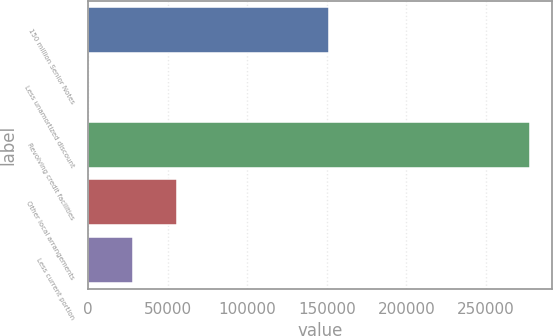<chart> <loc_0><loc_0><loc_500><loc_500><bar_chart><fcel>150 million Senior Notes<fcel>Less unamortized discount<fcel>Revolving credit facilities<fcel>Other local arrangements<fcel>Less current portion<nl><fcel>151527<fcel>66<fcel>277785<fcel>55609.8<fcel>27837.9<nl></chart> 